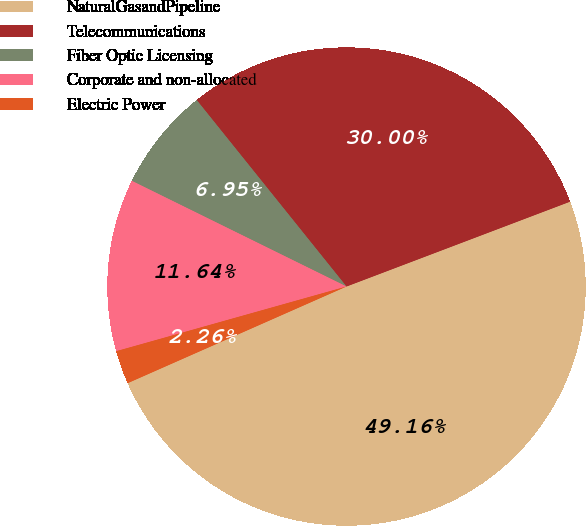<chart> <loc_0><loc_0><loc_500><loc_500><pie_chart><fcel>NaturalGasandPipeline<fcel>Telecommunications<fcel>Fiber Optic Licensing<fcel>Corporate and non-allocated<fcel>Electric Power<nl><fcel>49.16%<fcel>30.0%<fcel>6.95%<fcel>11.64%<fcel>2.26%<nl></chart> 